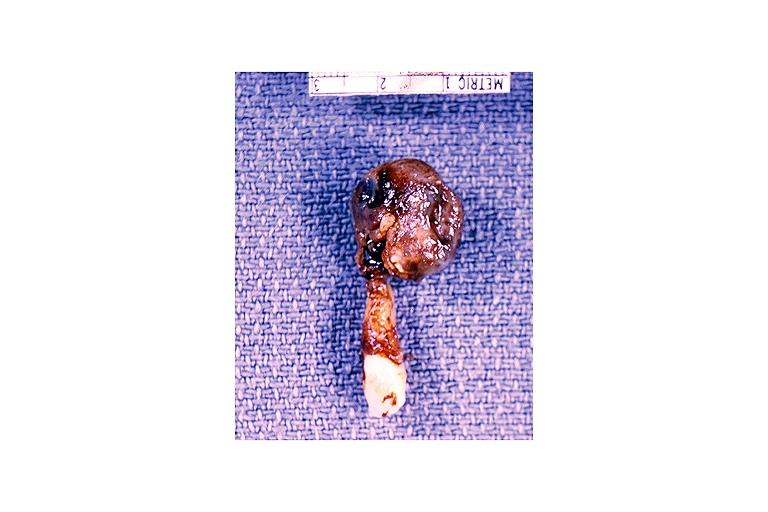what does this image show?
Answer the question using a single word or phrase. Radicular cyst 